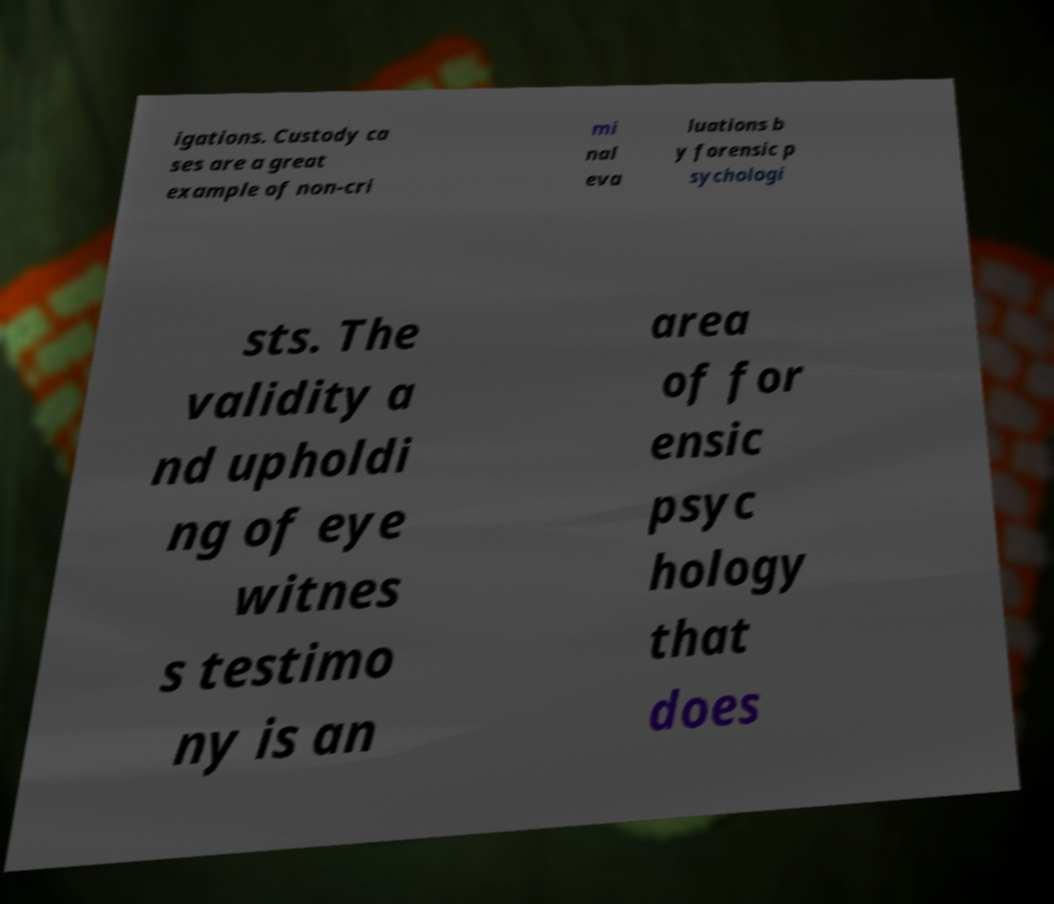Could you extract and type out the text from this image? igations. Custody ca ses are a great example of non-cri mi nal eva luations b y forensic p sychologi sts. The validity a nd upholdi ng of eye witnes s testimo ny is an area of for ensic psyc hology that does 